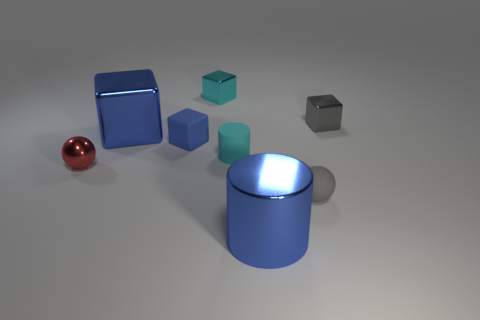What can you infer about the material of the objects based on their appearance? Based on the reflections and shine exhibited by the objects, it seems they are made of materials with a high degree of specular reflectivity, possibly metals or polished plastics. The red ball, for instance, shows a clear reflection indicative of a smooth, reflective surface. 